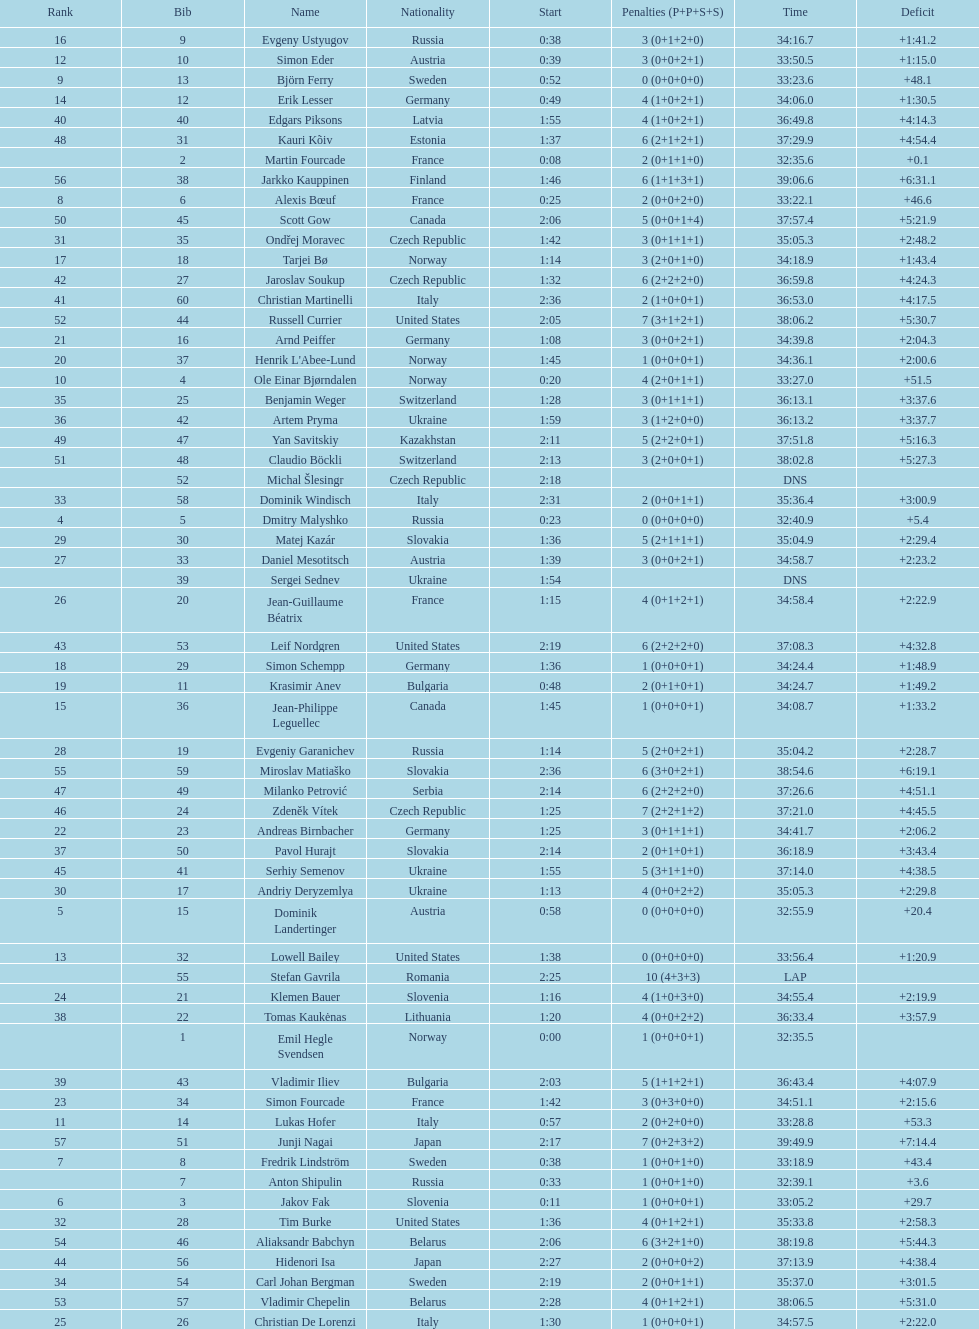I'm looking to parse the entire table for insights. Could you assist me with that? {'header': ['Rank', 'Bib', 'Name', 'Nationality', 'Start', 'Penalties (P+P+S+S)', 'Time', 'Deficit'], 'rows': [['16', '9', 'Evgeny Ustyugov', 'Russia', '0:38', '3 (0+1+2+0)', '34:16.7', '+1:41.2'], ['12', '10', 'Simon Eder', 'Austria', '0:39', '3 (0+0+2+1)', '33:50.5', '+1:15.0'], ['9', '13', 'Björn Ferry', 'Sweden', '0:52', '0 (0+0+0+0)', '33:23.6', '+48.1'], ['14', '12', 'Erik Lesser', 'Germany', '0:49', '4 (1+0+2+1)', '34:06.0', '+1:30.5'], ['40', '40', 'Edgars Piksons', 'Latvia', '1:55', '4 (1+0+2+1)', '36:49.8', '+4:14.3'], ['48', '31', 'Kauri Kõiv', 'Estonia', '1:37', '6 (2+1+2+1)', '37:29.9', '+4:54.4'], ['', '2', 'Martin Fourcade', 'France', '0:08', '2 (0+1+1+0)', '32:35.6', '+0.1'], ['56', '38', 'Jarkko Kauppinen', 'Finland', '1:46', '6 (1+1+3+1)', '39:06.6', '+6:31.1'], ['8', '6', 'Alexis Bœuf', 'France', '0:25', '2 (0+0+2+0)', '33:22.1', '+46.6'], ['50', '45', 'Scott Gow', 'Canada', '2:06', '5 (0+0+1+4)', '37:57.4', '+5:21.9'], ['31', '35', 'Ondřej Moravec', 'Czech Republic', '1:42', '3 (0+1+1+1)', '35:05.3', '+2:48.2'], ['17', '18', 'Tarjei Bø', 'Norway', '1:14', '3 (2+0+1+0)', '34:18.9', '+1:43.4'], ['42', '27', 'Jaroslav Soukup', 'Czech Republic', '1:32', '6 (2+2+2+0)', '36:59.8', '+4:24.3'], ['41', '60', 'Christian Martinelli', 'Italy', '2:36', '2 (1+0+0+1)', '36:53.0', '+4:17.5'], ['52', '44', 'Russell Currier', 'United States', '2:05', '7 (3+1+2+1)', '38:06.2', '+5:30.7'], ['21', '16', 'Arnd Peiffer', 'Germany', '1:08', '3 (0+0+2+1)', '34:39.8', '+2:04.3'], ['20', '37', "Henrik L'Abee-Lund", 'Norway', '1:45', '1 (0+0+0+1)', '34:36.1', '+2:00.6'], ['10', '4', 'Ole Einar Bjørndalen', 'Norway', '0:20', '4 (2+0+1+1)', '33:27.0', '+51.5'], ['35', '25', 'Benjamin Weger', 'Switzerland', '1:28', '3 (0+1+1+1)', '36:13.1', '+3:37.6'], ['36', '42', 'Artem Pryma', 'Ukraine', '1:59', '3 (1+2+0+0)', '36:13.2', '+3:37.7'], ['49', '47', 'Yan Savitskiy', 'Kazakhstan', '2:11', '5 (2+2+0+1)', '37:51.8', '+5:16.3'], ['51', '48', 'Claudio Böckli', 'Switzerland', '2:13', '3 (2+0+0+1)', '38:02.8', '+5:27.3'], ['', '52', 'Michal Šlesingr', 'Czech Republic', '2:18', '', 'DNS', ''], ['33', '58', 'Dominik Windisch', 'Italy', '2:31', '2 (0+0+1+1)', '35:36.4', '+3:00.9'], ['4', '5', 'Dmitry Malyshko', 'Russia', '0:23', '0 (0+0+0+0)', '32:40.9', '+5.4'], ['29', '30', 'Matej Kazár', 'Slovakia', '1:36', '5 (2+1+1+1)', '35:04.9', '+2:29.4'], ['27', '33', 'Daniel Mesotitsch', 'Austria', '1:39', '3 (0+0+2+1)', '34:58.7', '+2:23.2'], ['', '39', 'Sergei Sednev', 'Ukraine', '1:54', '', 'DNS', ''], ['26', '20', 'Jean-Guillaume Béatrix', 'France', '1:15', '4 (0+1+2+1)', '34:58.4', '+2:22.9'], ['43', '53', 'Leif Nordgren', 'United States', '2:19', '6 (2+2+2+0)', '37:08.3', '+4:32.8'], ['18', '29', 'Simon Schempp', 'Germany', '1:36', '1 (0+0+0+1)', '34:24.4', '+1:48.9'], ['19', '11', 'Krasimir Anev', 'Bulgaria', '0:48', '2 (0+1+0+1)', '34:24.7', '+1:49.2'], ['15', '36', 'Jean-Philippe Leguellec', 'Canada', '1:45', '1 (0+0+0+1)', '34:08.7', '+1:33.2'], ['28', '19', 'Evgeniy Garanichev', 'Russia', '1:14', '5 (2+0+2+1)', '35:04.2', '+2:28.7'], ['55', '59', 'Miroslav Matiaško', 'Slovakia', '2:36', '6 (3+0+2+1)', '38:54.6', '+6:19.1'], ['47', '49', 'Milanko Petrović', 'Serbia', '2:14', '6 (2+2+2+0)', '37:26.6', '+4:51.1'], ['46', '24', 'Zdeněk Vítek', 'Czech Republic', '1:25', '7 (2+2+1+2)', '37:21.0', '+4:45.5'], ['22', '23', 'Andreas Birnbacher', 'Germany', '1:25', '3 (0+1+1+1)', '34:41.7', '+2:06.2'], ['37', '50', 'Pavol Hurajt', 'Slovakia', '2:14', '2 (0+1+0+1)', '36:18.9', '+3:43.4'], ['45', '41', 'Serhiy Semenov', 'Ukraine', '1:55', '5 (3+1+1+0)', '37:14.0', '+4:38.5'], ['30', '17', 'Andriy Deryzemlya', 'Ukraine', '1:13', '4 (0+0+2+2)', '35:05.3', '+2:29.8'], ['5', '15', 'Dominik Landertinger', 'Austria', '0:58', '0 (0+0+0+0)', '32:55.9', '+20.4'], ['13', '32', 'Lowell Bailey', 'United States', '1:38', '0 (0+0+0+0)', '33:56.4', '+1:20.9'], ['', '55', 'Stefan Gavrila', 'Romania', '2:25', '10 (4+3+3)', 'LAP', ''], ['24', '21', 'Klemen Bauer', 'Slovenia', '1:16', '4 (1+0+3+0)', '34:55.4', '+2:19.9'], ['38', '22', 'Tomas Kaukėnas', 'Lithuania', '1:20', '4 (0+0+2+2)', '36:33.4', '+3:57.9'], ['', '1', 'Emil Hegle Svendsen', 'Norway', '0:00', '1 (0+0+0+1)', '32:35.5', ''], ['39', '43', 'Vladimir Iliev', 'Bulgaria', '2:03', '5 (1+1+2+1)', '36:43.4', '+4:07.9'], ['23', '34', 'Simon Fourcade', 'France', '1:42', '3 (0+3+0+0)', '34:51.1', '+2:15.6'], ['11', '14', 'Lukas Hofer', 'Italy', '0:57', '2 (0+2+0+0)', '33:28.8', '+53.3'], ['57', '51', 'Junji Nagai', 'Japan', '2:17', '7 (0+2+3+2)', '39:49.9', '+7:14.4'], ['7', '8', 'Fredrik Lindström', 'Sweden', '0:38', '1 (0+0+1+0)', '33:18.9', '+43.4'], ['', '7', 'Anton Shipulin', 'Russia', '0:33', '1 (0+0+1+0)', '32:39.1', '+3.6'], ['6', '3', 'Jakov Fak', 'Slovenia', '0:11', '1 (0+0+0+1)', '33:05.2', '+29.7'], ['32', '28', 'Tim Burke', 'United States', '1:36', '4 (0+1+2+1)', '35:33.8', '+2:58.3'], ['54', '46', 'Aliaksandr Babchyn', 'Belarus', '2:06', '6 (3+2+1+0)', '38:19.8', '+5:44.3'], ['44', '56', 'Hidenori Isa', 'Japan', '2:27', '2 (0+0+0+2)', '37:13.9', '+4:38.4'], ['34', '54', 'Carl Johan Bergman', 'Sweden', '2:19', '2 (0+0+1+1)', '35:37.0', '+3:01.5'], ['53', '57', 'Vladimir Chepelin', 'Belarus', '2:28', '4 (0+1+2+1)', '38:06.5', '+5:31.0'], ['25', '26', 'Christian De Lorenzi', 'Italy', '1:30', '1 (0+0+0+1)', '34:57.5', '+2:22.0']]} How many took at least 35:00 to finish? 30. 